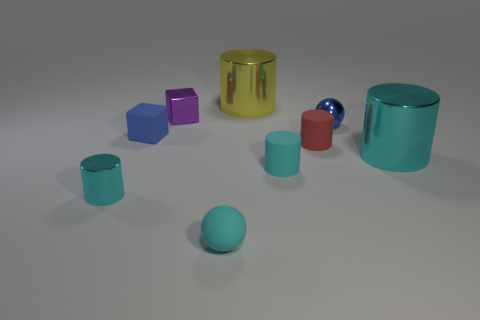Subtract all brown cubes. How many cyan cylinders are left? 3 Subtract all small cyan matte cylinders. How many cylinders are left? 4 Subtract all red cylinders. How many cylinders are left? 4 Subtract all blue cylinders. Subtract all red spheres. How many cylinders are left? 5 Add 1 green shiny spheres. How many objects exist? 10 Subtract all cylinders. How many objects are left? 4 Add 6 tiny cyan rubber things. How many tiny cyan rubber things exist? 8 Subtract 0 red blocks. How many objects are left? 9 Subtract all tiny cyan rubber things. Subtract all tiny purple blocks. How many objects are left? 6 Add 6 cyan spheres. How many cyan spheres are left? 7 